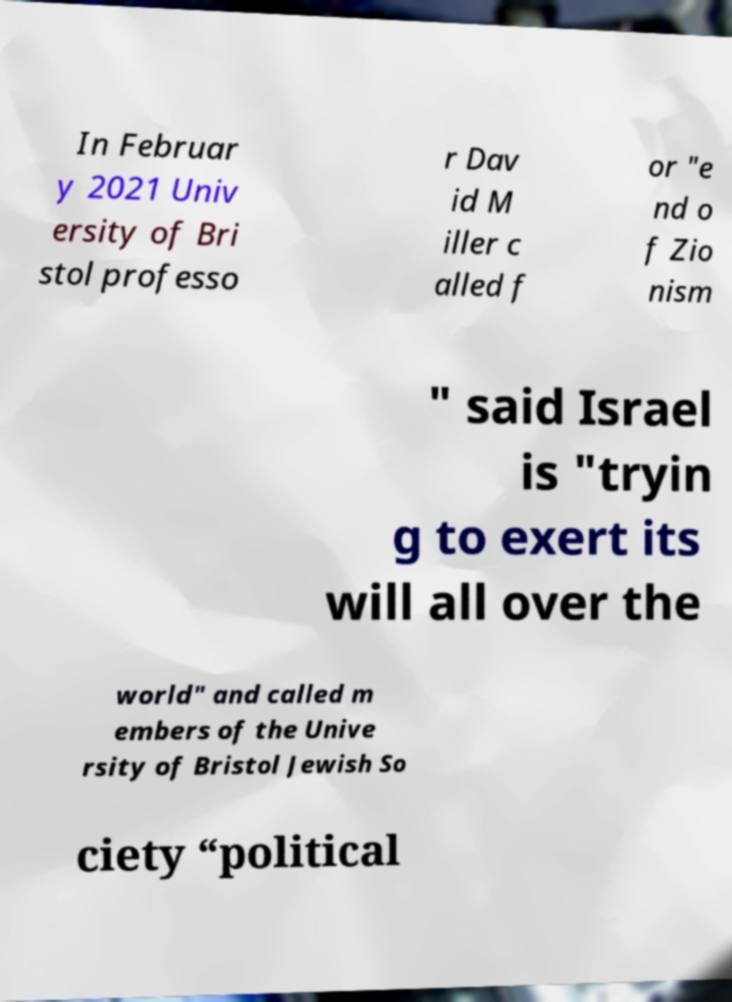Please read and relay the text visible in this image. What does it say? In Februar y 2021 Univ ersity of Bri stol professo r Dav id M iller c alled f or "e nd o f Zio nism " said Israel is "tryin g to exert its will all over the world" and called m embers of the Unive rsity of Bristol Jewish So ciety “political 